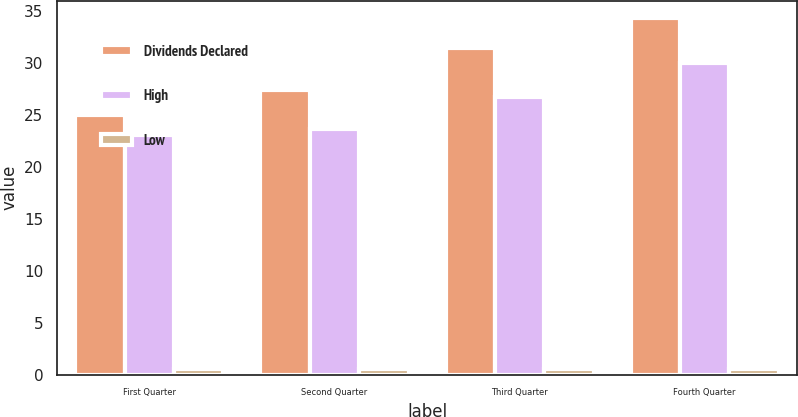Convert chart. <chart><loc_0><loc_0><loc_500><loc_500><stacked_bar_chart><ecel><fcel>First Quarter<fcel>Second Quarter<fcel>Third Quarter<fcel>Fourth Quarter<nl><fcel>Dividends Declared<fcel>24.98<fcel>27.45<fcel>31.45<fcel>34.29<nl><fcel>High<fcel>23.1<fcel>23.67<fcel>26.74<fcel>30.02<nl><fcel>Low<fcel>0.58<fcel>0.58<fcel>0.58<fcel>0.58<nl></chart> 